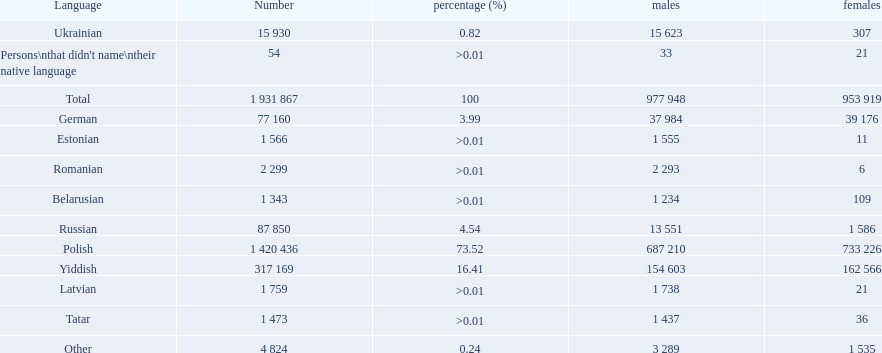What were all the languages? Polish, Yiddish, Russian, German, Ukrainian, Romanian, Latvian, Estonian, Tatar, Belarusian, Other, Persons\nthat didn't name\ntheir native language. For these, how many people spoke them? 1 420 436, 317 169, 87 850, 77 160, 15 930, 2 299, 1 759, 1 566, 1 473, 1 343, 4 824, 54. Of these, which is the largest number of speakers? 1 420 436. Which language corresponds to this number? Polish. 